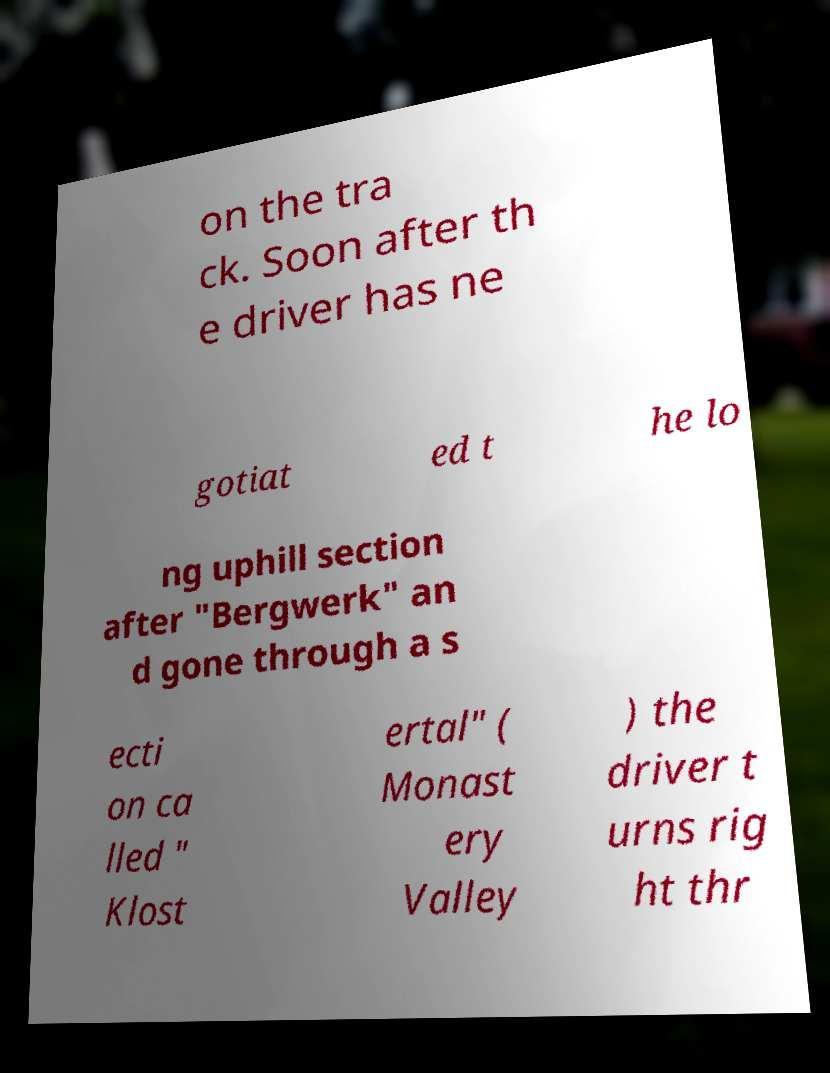Please identify and transcribe the text found in this image. on the tra ck. Soon after th e driver has ne gotiat ed t he lo ng uphill section after "Bergwerk" an d gone through a s ecti on ca lled " Klost ertal" ( Monast ery Valley ) the driver t urns rig ht thr 